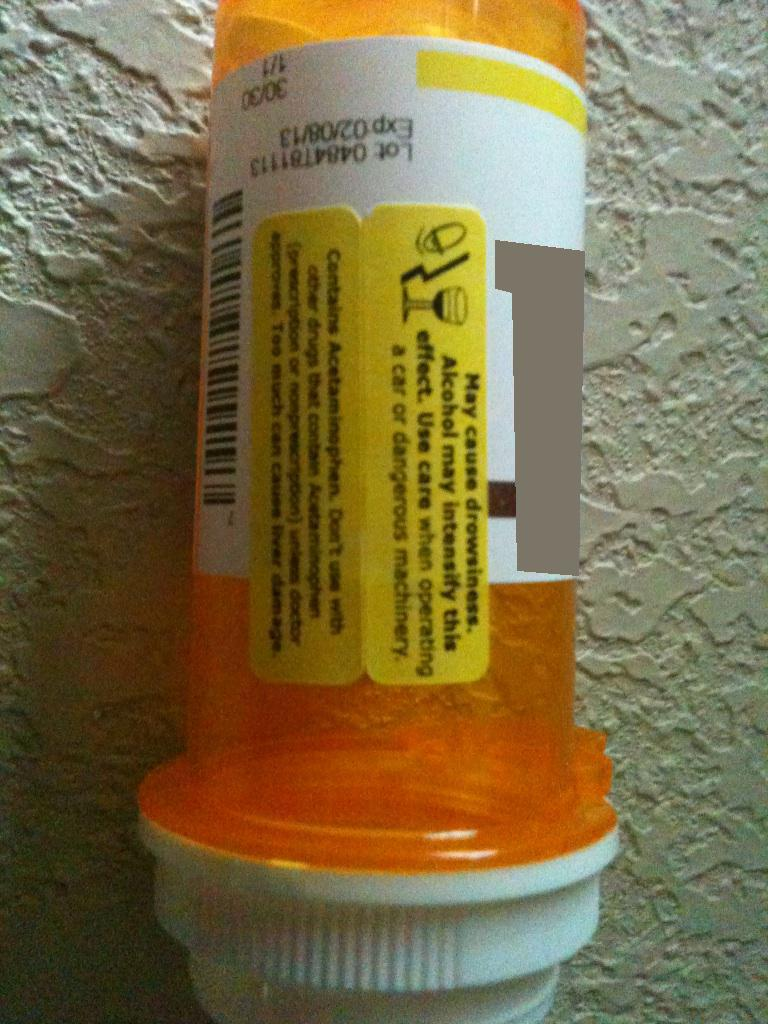What's the warning label? The warning label on this prescription bottle states: 'May cause drowsiness. Alcohol may intensify this effect. Use care when operating a car or dangerous machinery. Contains Acetaminophen. Doses exceeding recommendations may cause liver damage. Do not take with other drugs containing acetaminophen.' 